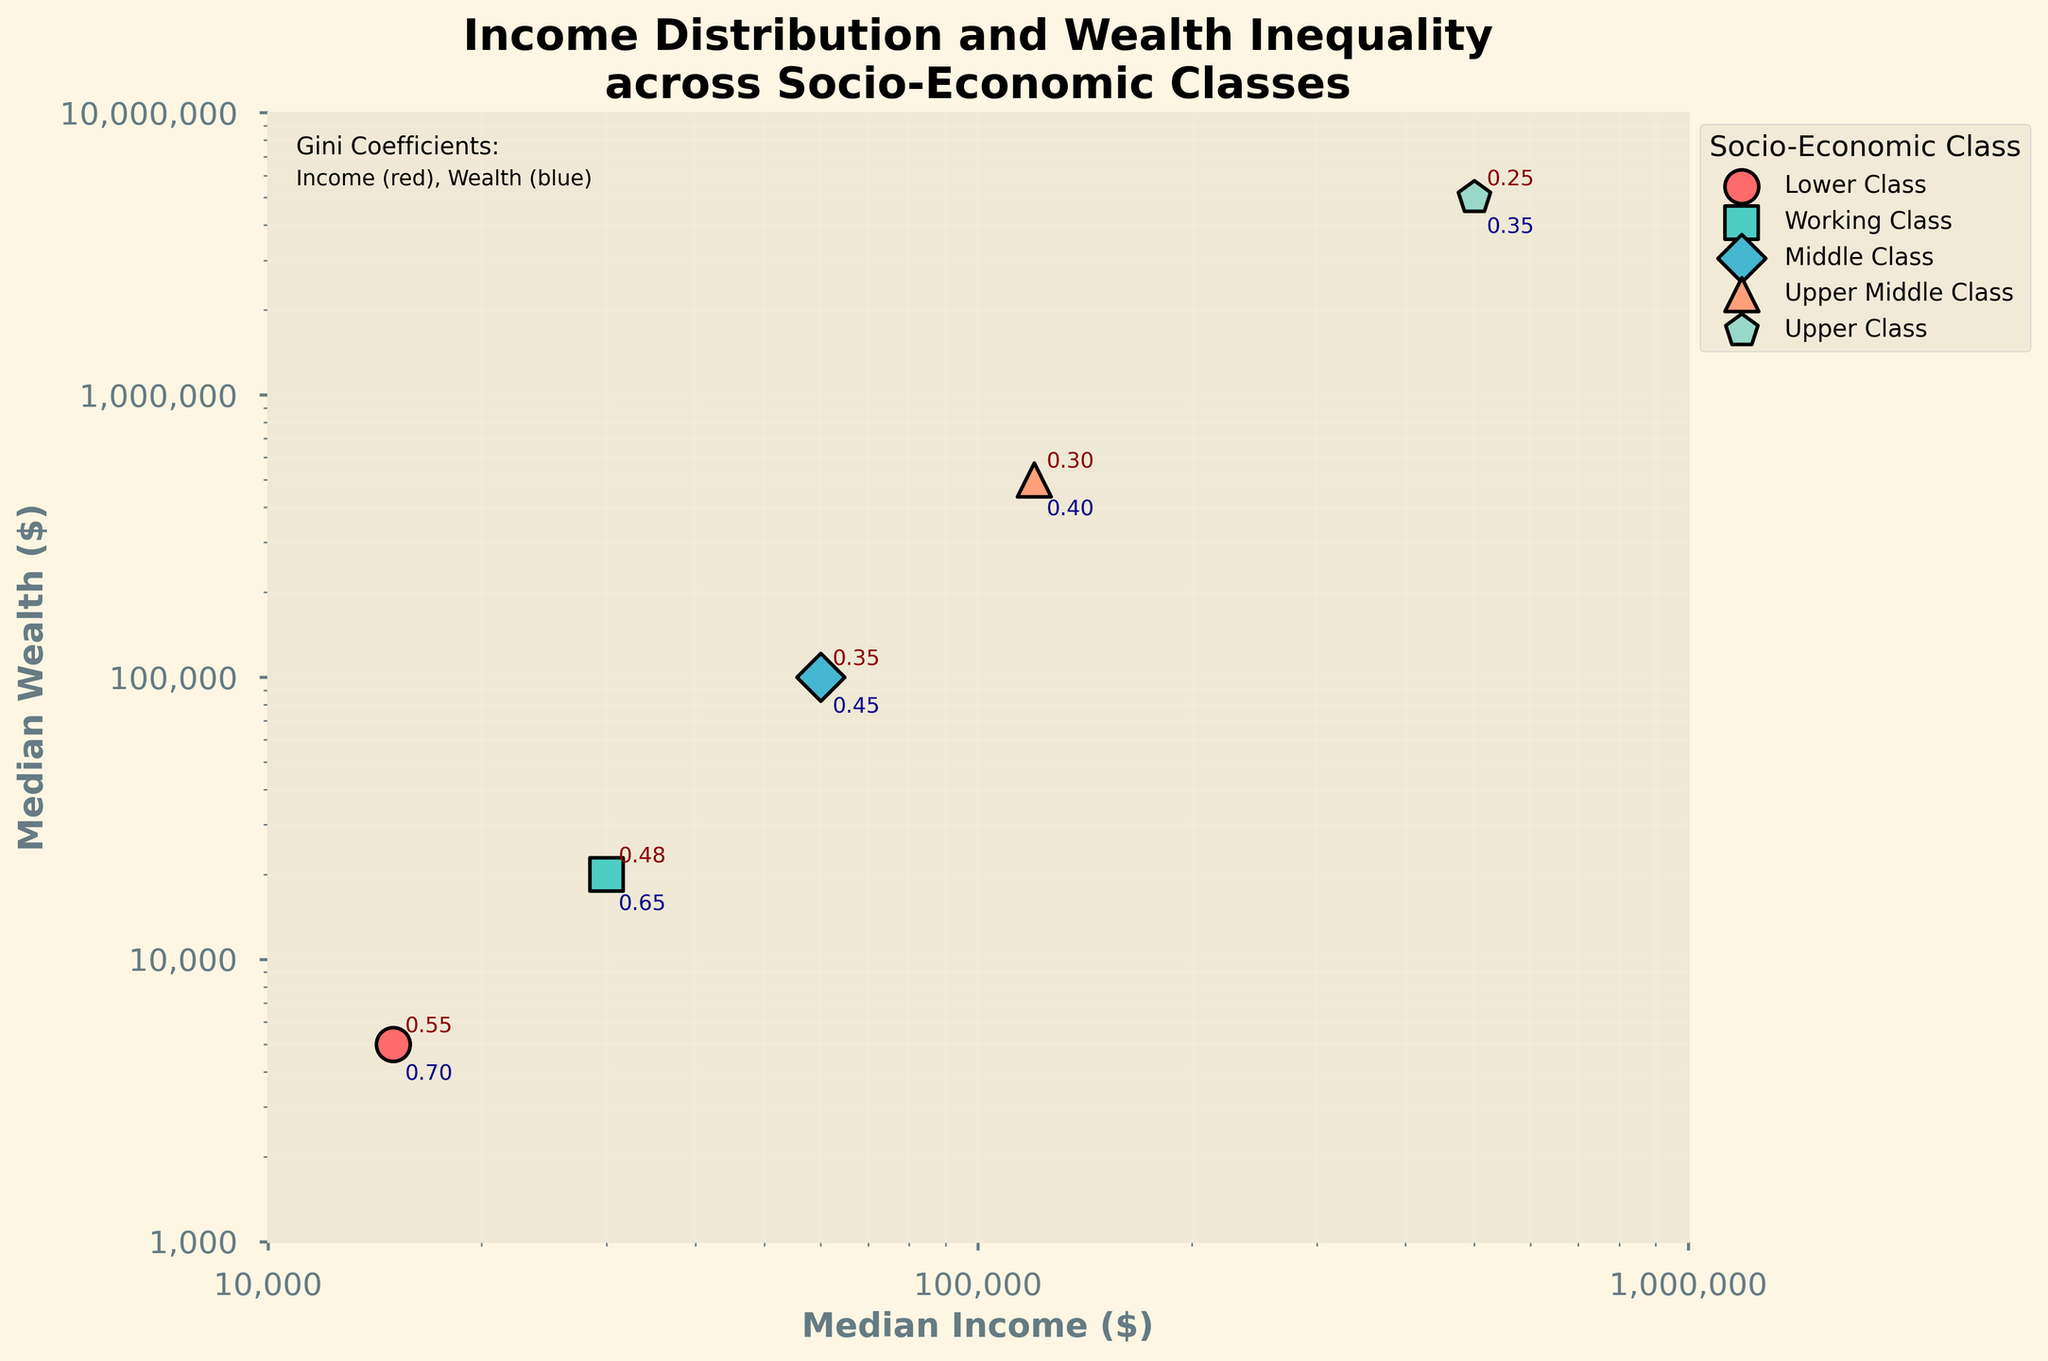What are the axes labels on the figure? The x-axis label is "Median Income ($)" and the y-axis label is "Median Wealth ($)". This information is explicitly shown on the plot where each axis is annotated.
Answer: Median Income ($), Median Wealth ($) How is the title of the figure described? The title of the figure is "Income Distribution and Wealth Inequality across Socio-Economic Classes". This is located at the top of the plot in bold text.
Answer: Income Distribution and Wealth Inequality across Socio-Economic Classes Which socio-economic class has the highest median income? The upper class has the highest median income at $500,000. This is shown on the plot where each data point is labeled, and the data point for the upper class is positioned furthest to the right on the x-axis.
Answer: Upper Class Where can the Gini coefficients for income and wealth be found on the figure? Gini coefficients for income (red) and wealth (blue) are annotated near each data point. Additionally, there is a text note in the top-left corner clarifying these colors.
Answer: Next to data points and in the top-left corner What is the relationship between median income and median wealth as depicted in the figure? Generally, as median income increases, median wealth also increases. This relationship is visually evidenced by the upward trend in the scatter plot on the log-log scale.
Answer: Positive correlation How does the median wealth of the upper middle class compare to that of the middle class? The median wealth of the upper middle class is $500,000, while that of the middle class is $100,000. This indicates that the upper middle class has a median wealth that is 5 times greater than that of the middle class.
Answer: 5 times greater Which socio-economic class shows the highest Gini coefficient for wealth? The lower class shows the highest Gini coefficient for wealth at 0.70. This information is annotated directly on the figure near the data point representing the lower class.
Answer: Lower Class What is the range of median incomes covered in the plot? The range of median incomes covered in the plot is from $15,000 to $500,000. These values can be seen from the least and most rightward data points on the x-axis.
Answer: $15,000 to $500,000 Identify the socio-economic classes with a Gini income coefficient less than 0.40. The socio-economic classes with Gini income coefficients less than 0.40 are the middle class (0.35), upper middle class (0.30), and upper class (0.25). This information is annotated near the respective data points.
Answer: Middle Class, Upper Middle Class, Upper Class What visual elements differentiate the socio-economic classes in the figure? Different socio-economic classes are differentiated by distinct colors and markers for each group. Each class has a unique combination of these visual elements to distinguish them on the scatter plot.
Answer: Colors, Markers 